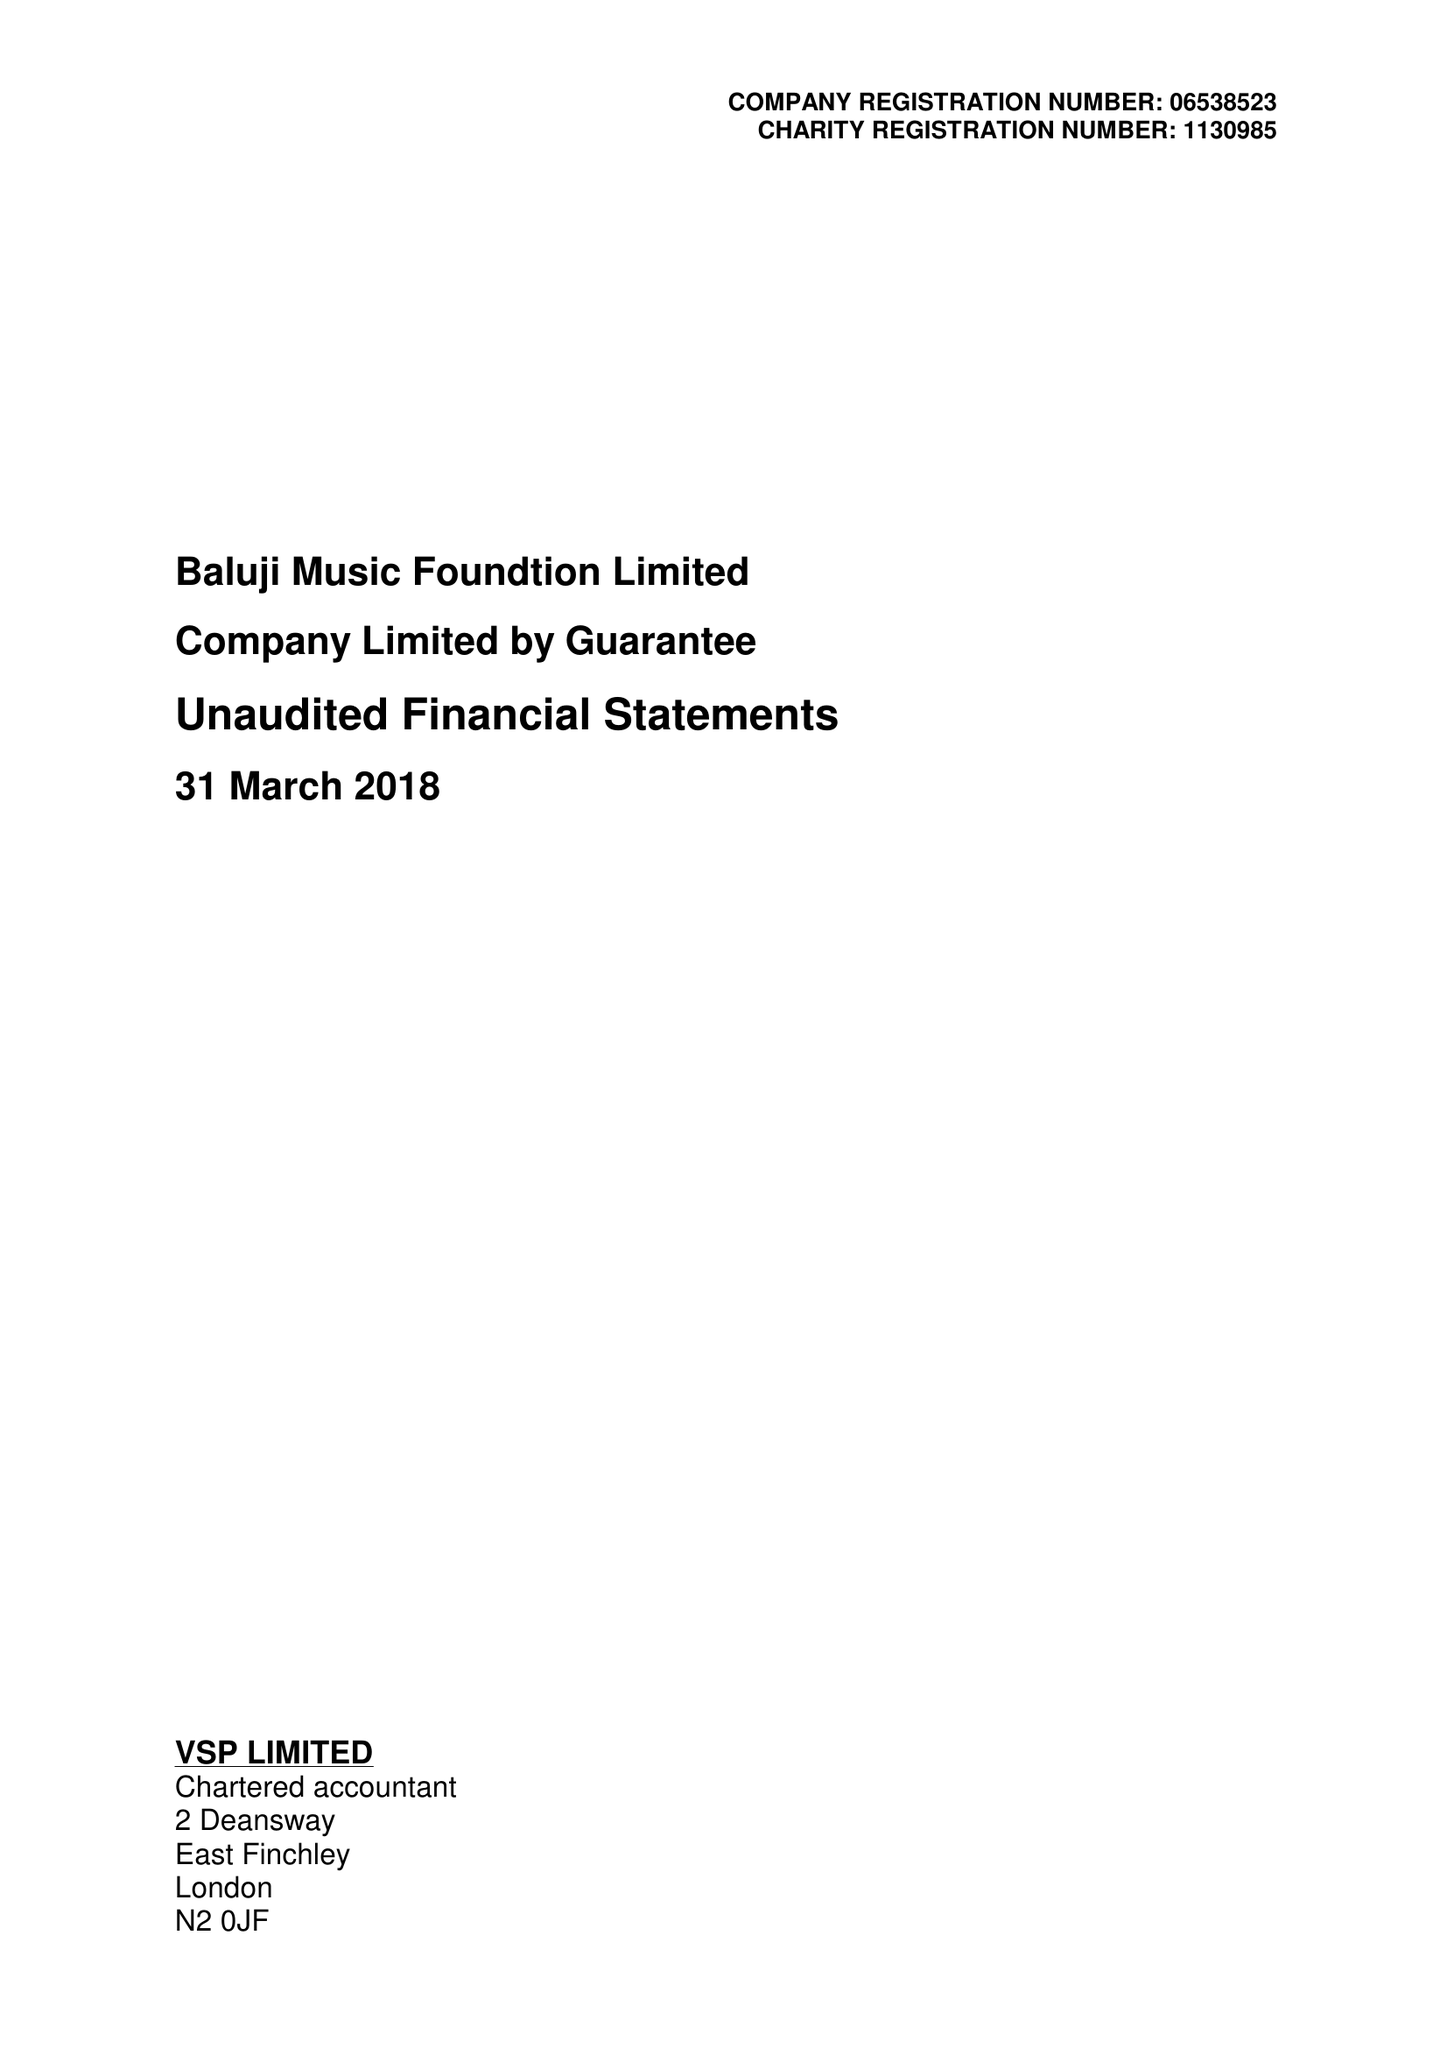What is the value for the charity_name?
Answer the question using a single word or phrase. Baluji Music Foundation Ltd. 